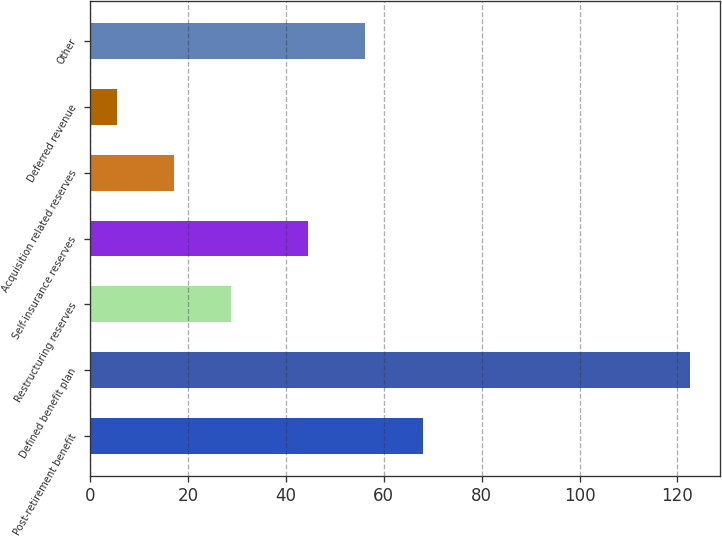Convert chart. <chart><loc_0><loc_0><loc_500><loc_500><bar_chart><fcel>Post-retirement benefit<fcel>Defined benefit plan<fcel>Restructuring reserves<fcel>Self-insurance reserves<fcel>Acquisition related reserves<fcel>Deferred revenue<fcel>Other<nl><fcel>67.92<fcel>122.5<fcel>28.82<fcel>44.5<fcel>17.11<fcel>5.4<fcel>56.21<nl></chart> 